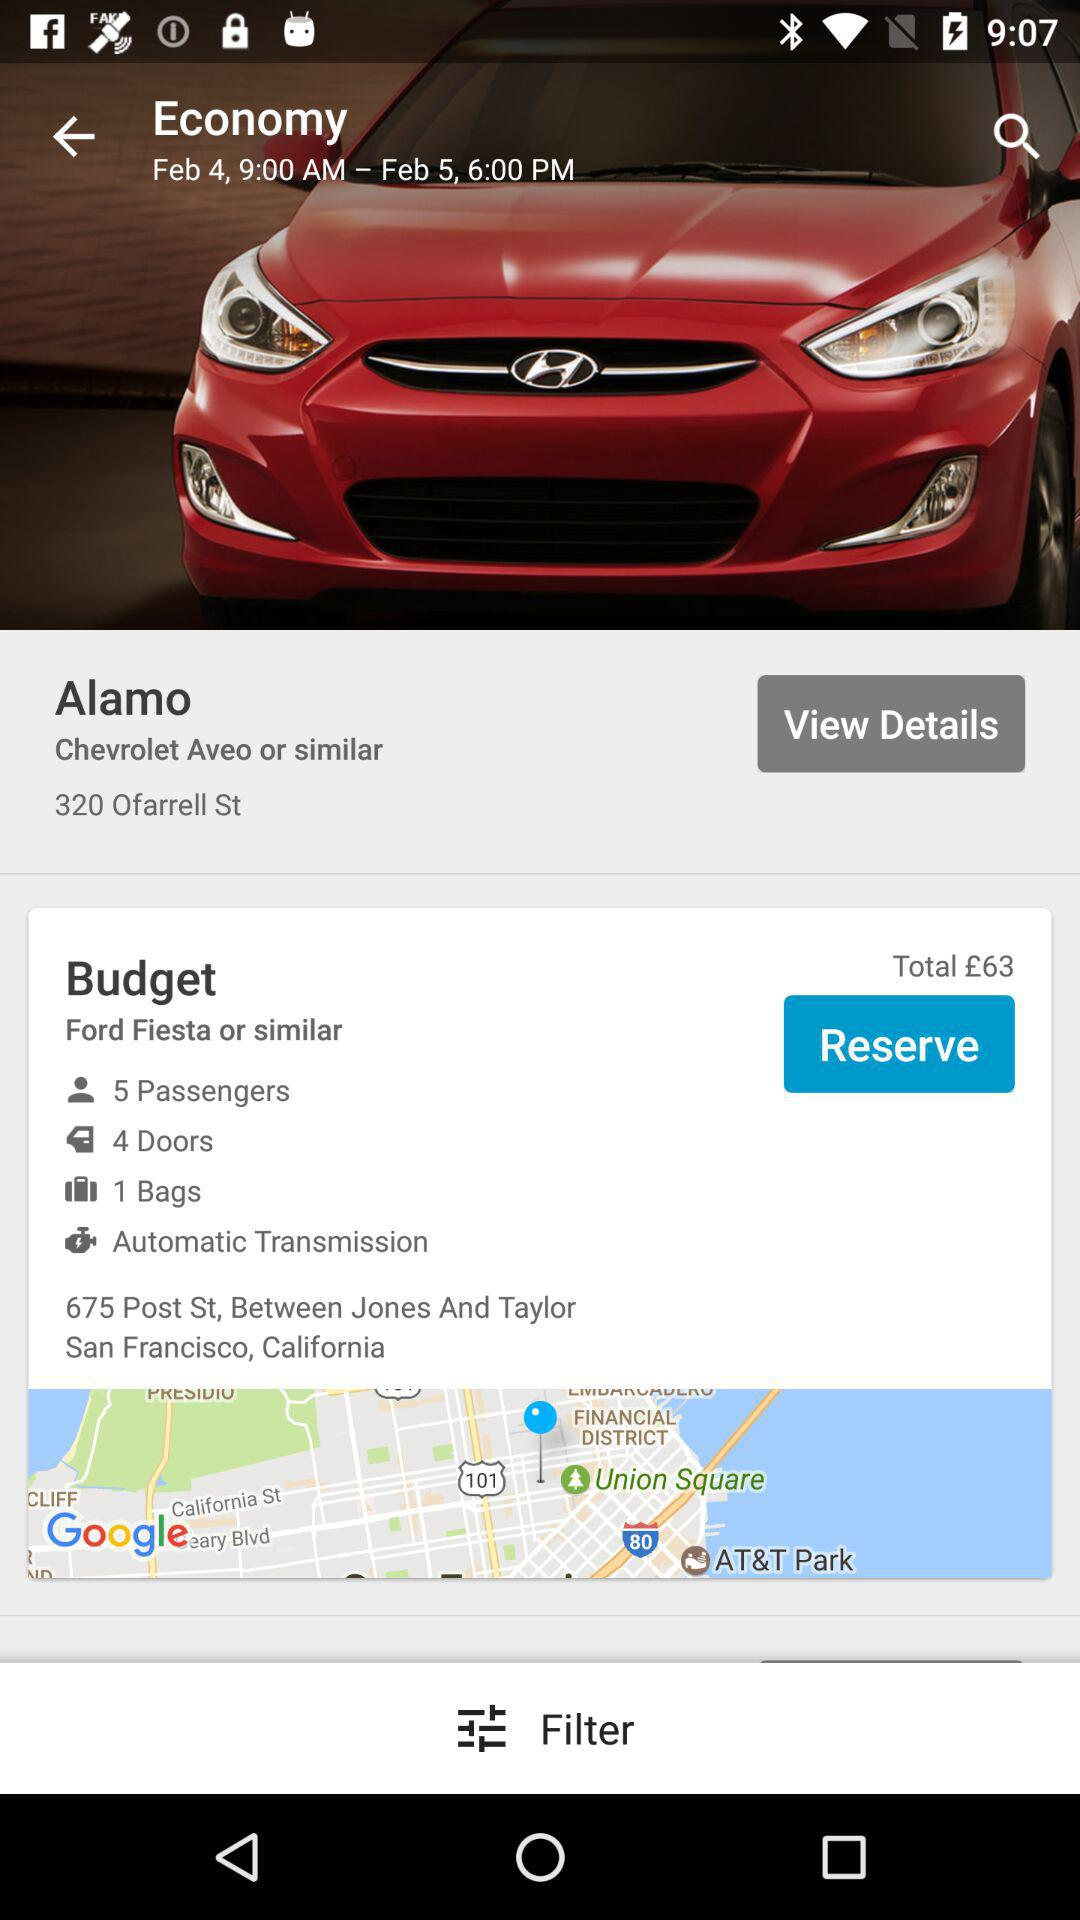How many doors are there? There are 4 doors. 